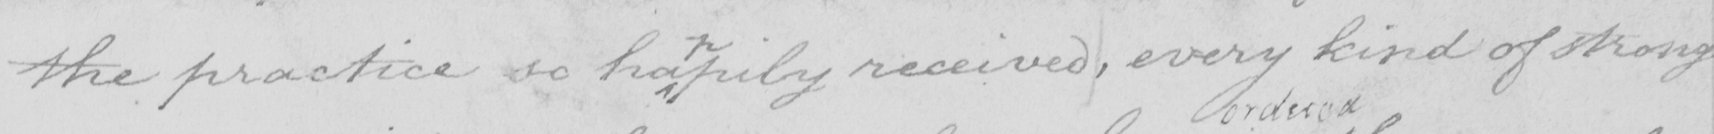Transcribe the text shown in this historical manuscript line. the practice so ha pily received , every kind of strong 